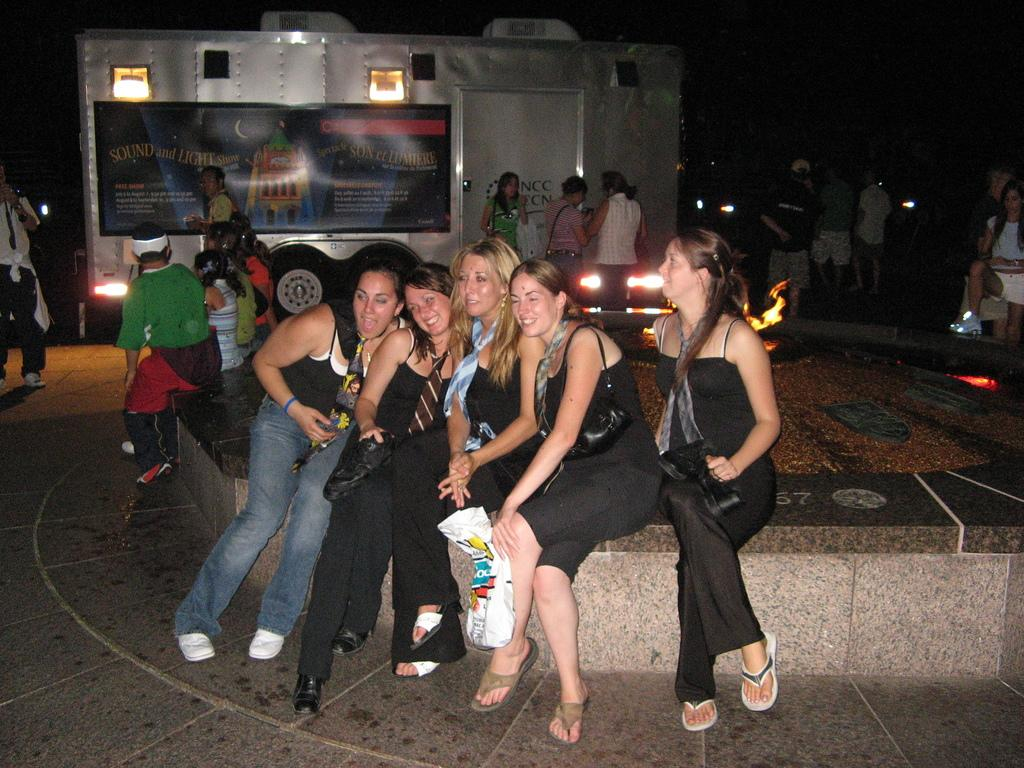How many women are sitting together on the wall in the image? There are five women sitting together on the wall in the image. Are there any other people in the image besides the women on the wall? Yes, there are people sitting beside the wall in the image. What can be seen in the background of the image? A generator vehicle is visible in the background of the image. What type of birthday celebration is happening in the image? There is no indication of a birthday celebration in the image. Can you see a trampoline in the image? There is no trampoline present in the image. 